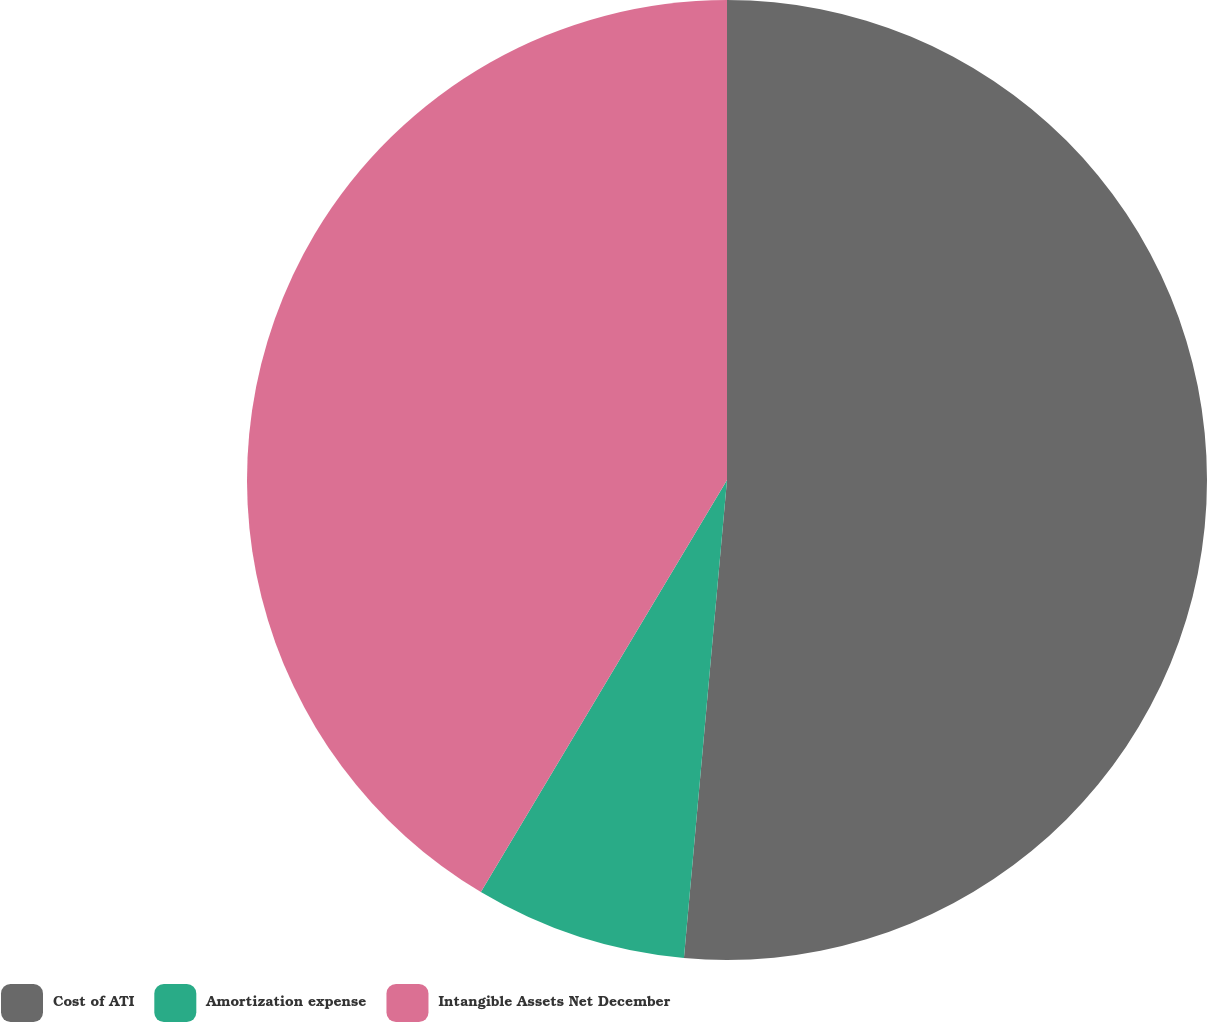Convert chart. <chart><loc_0><loc_0><loc_500><loc_500><pie_chart><fcel>Cost of ATI<fcel>Amortization expense<fcel>Intangible Assets Net December<nl><fcel>51.43%<fcel>7.14%<fcel>41.43%<nl></chart> 